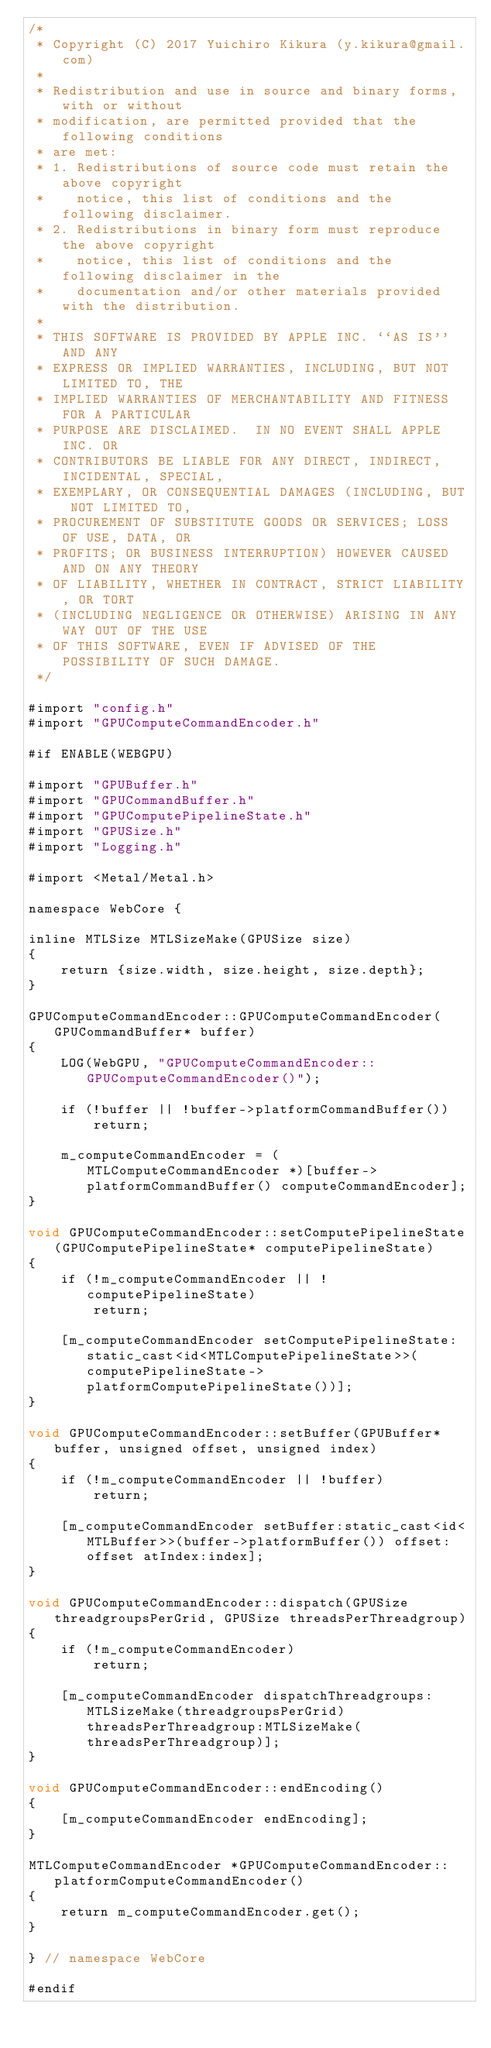<code> <loc_0><loc_0><loc_500><loc_500><_ObjectiveC_>/*
 * Copyright (C) 2017 Yuichiro Kikura (y.kikura@gmail.com)
 *
 * Redistribution and use in source and binary forms, with or without
 * modification, are permitted provided that the following conditions
 * are met:
 * 1. Redistributions of source code must retain the above copyright
 *    notice, this list of conditions and the following disclaimer.
 * 2. Redistributions in binary form must reproduce the above copyright
 *    notice, this list of conditions and the following disclaimer in the
 *    documentation and/or other materials provided with the distribution.
 *
 * THIS SOFTWARE IS PROVIDED BY APPLE INC. ``AS IS'' AND ANY
 * EXPRESS OR IMPLIED WARRANTIES, INCLUDING, BUT NOT LIMITED TO, THE
 * IMPLIED WARRANTIES OF MERCHANTABILITY AND FITNESS FOR A PARTICULAR
 * PURPOSE ARE DISCLAIMED.  IN NO EVENT SHALL APPLE INC. OR
 * CONTRIBUTORS BE LIABLE FOR ANY DIRECT, INDIRECT, INCIDENTAL, SPECIAL,
 * EXEMPLARY, OR CONSEQUENTIAL DAMAGES (INCLUDING, BUT NOT LIMITED TO,
 * PROCUREMENT OF SUBSTITUTE GOODS OR SERVICES; LOSS OF USE, DATA, OR
 * PROFITS; OR BUSINESS INTERRUPTION) HOWEVER CAUSED AND ON ANY THEORY
 * OF LIABILITY, WHETHER IN CONTRACT, STRICT LIABILITY, OR TORT
 * (INCLUDING NEGLIGENCE OR OTHERWISE) ARISING IN ANY WAY OUT OF THE USE
 * OF THIS SOFTWARE, EVEN IF ADVISED OF THE POSSIBILITY OF SUCH DAMAGE.
 */

#import "config.h"
#import "GPUComputeCommandEncoder.h"

#if ENABLE(WEBGPU)

#import "GPUBuffer.h"
#import "GPUCommandBuffer.h"
#import "GPUComputePipelineState.h"
#import "GPUSize.h"
#import "Logging.h"

#import <Metal/Metal.h>

namespace WebCore {
    
inline MTLSize MTLSizeMake(GPUSize size)
{
    return {size.width, size.height, size.depth};
}
    
GPUComputeCommandEncoder::GPUComputeCommandEncoder(GPUCommandBuffer* buffer)
{
    LOG(WebGPU, "GPUComputeCommandEncoder::GPUComputeCommandEncoder()");

    if (!buffer || !buffer->platformCommandBuffer())
        return;

    m_computeCommandEncoder = (MTLComputeCommandEncoder *)[buffer->platformCommandBuffer() computeCommandEncoder];
}
    
void GPUComputeCommandEncoder::setComputePipelineState(GPUComputePipelineState* computePipelineState)
{
    if (!m_computeCommandEncoder || !computePipelineState)
        return;
    
    [m_computeCommandEncoder setComputePipelineState:static_cast<id<MTLComputePipelineState>>(computePipelineState->platformComputePipelineState())];
}
    
void GPUComputeCommandEncoder::setBuffer(GPUBuffer* buffer, unsigned offset, unsigned index)
{
    if (!m_computeCommandEncoder || !buffer)
        return;
    
    [m_computeCommandEncoder setBuffer:static_cast<id<MTLBuffer>>(buffer->platformBuffer()) offset:offset atIndex:index];
}
    
void GPUComputeCommandEncoder::dispatch(GPUSize threadgroupsPerGrid, GPUSize threadsPerThreadgroup)
{
    if (!m_computeCommandEncoder)
        return;
    
    [m_computeCommandEncoder dispatchThreadgroups:MTLSizeMake(threadgroupsPerGrid) threadsPerThreadgroup:MTLSizeMake(threadsPerThreadgroup)];
}

void GPUComputeCommandEncoder::endEncoding()
{
    [m_computeCommandEncoder endEncoding];
}
    
MTLComputeCommandEncoder *GPUComputeCommandEncoder::platformComputeCommandEncoder()
{
    return m_computeCommandEncoder.get();
}
    
} // namespace WebCore

#endif
</code> 